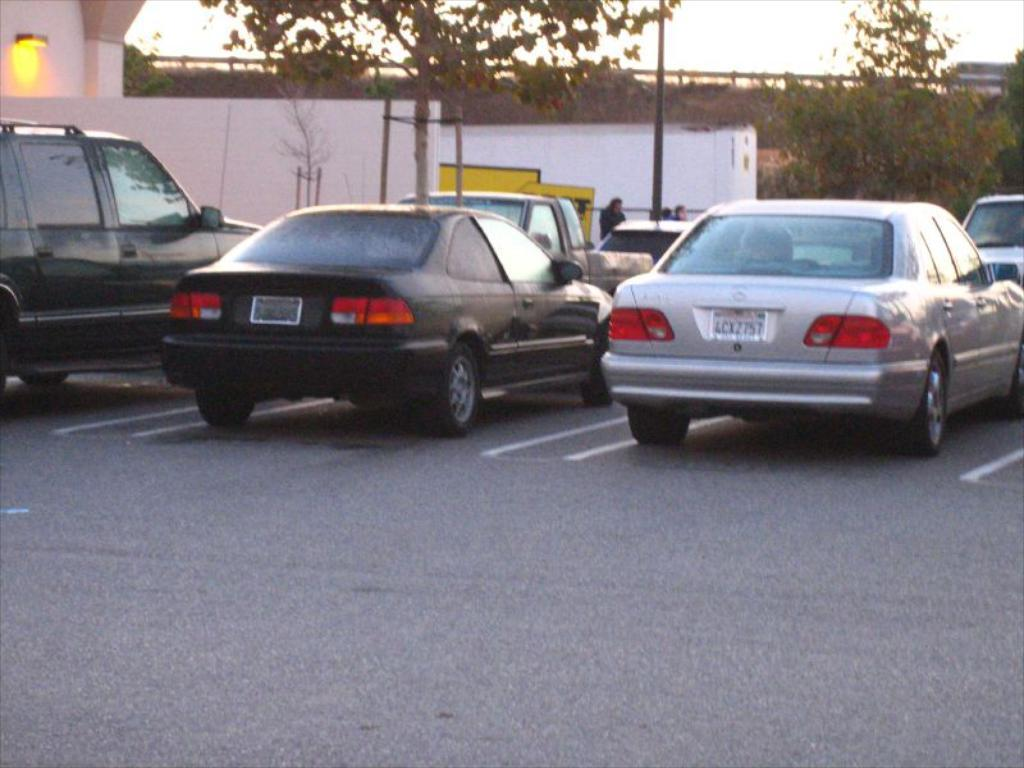What can be seen on the road in the image? There is a group of cars on the road in the image. What is the tall, vertical object in the image? There is a pole in the image. What type of vegetation is present in the image? Trees are present in the image. What is the structure made of bricks or concrete in the image? There is a wall in the image. What is the source of illumination in the image? There is a light in the image. What is visible above the ground in the image? The sky is visible in the image. What unit of measurement is used to adjust the height of the trees in the image? There is no mention of adjusting the height of the trees in the image, nor is there any reference to a unit of measurement. 